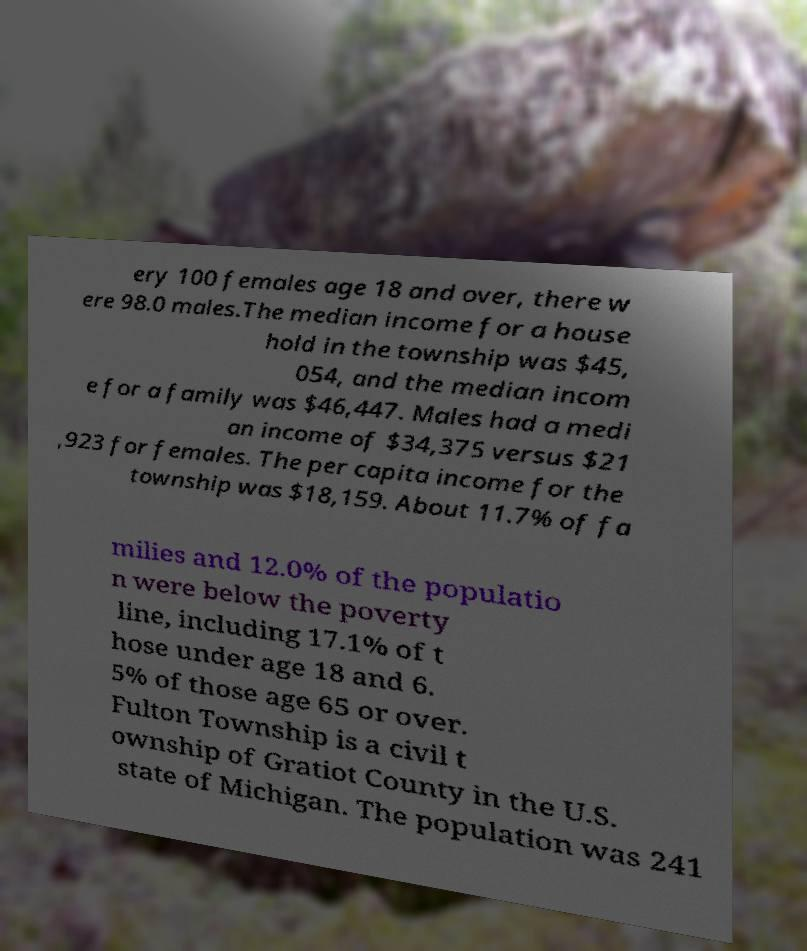For documentation purposes, I need the text within this image transcribed. Could you provide that? ery 100 females age 18 and over, there w ere 98.0 males.The median income for a house hold in the township was $45, 054, and the median incom e for a family was $46,447. Males had a medi an income of $34,375 versus $21 ,923 for females. The per capita income for the township was $18,159. About 11.7% of fa milies and 12.0% of the populatio n were below the poverty line, including 17.1% of t hose under age 18 and 6. 5% of those age 65 or over. Fulton Township is a civil t ownship of Gratiot County in the U.S. state of Michigan. The population was 241 